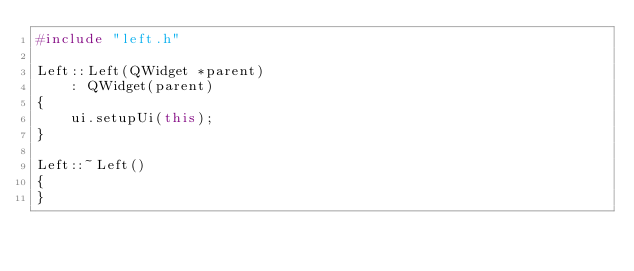<code> <loc_0><loc_0><loc_500><loc_500><_C++_>#include "left.h"

Left::Left(QWidget *parent)
	: QWidget(parent)
{
	ui.setupUi(this);
}

Left::~Left()
{
}
</code> 